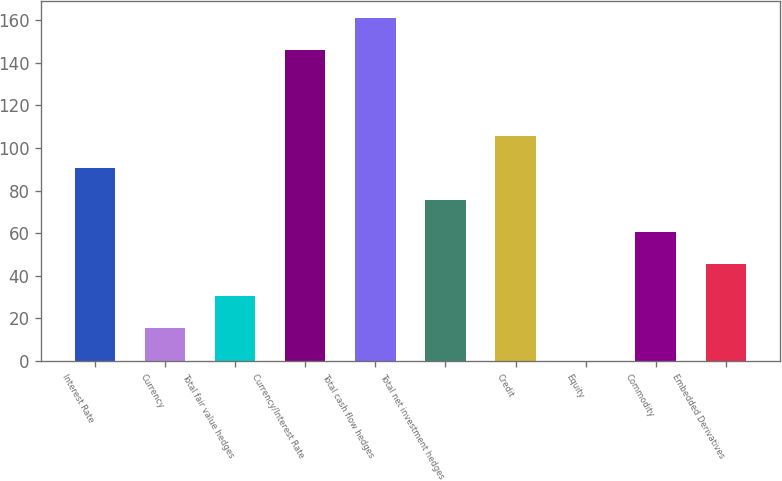<chart> <loc_0><loc_0><loc_500><loc_500><bar_chart><fcel>Interest Rate<fcel>Currency<fcel>Total fair value hedges<fcel>Currency/Interest Rate<fcel>Total cash flow hedges<fcel>Total net investment hedges<fcel>Credit<fcel>Equity<fcel>Commodity<fcel>Embedded Derivatives<nl><fcel>90.64<fcel>15.24<fcel>30.32<fcel>146<fcel>161.08<fcel>75.56<fcel>105.72<fcel>0.16<fcel>60.48<fcel>45.4<nl></chart> 